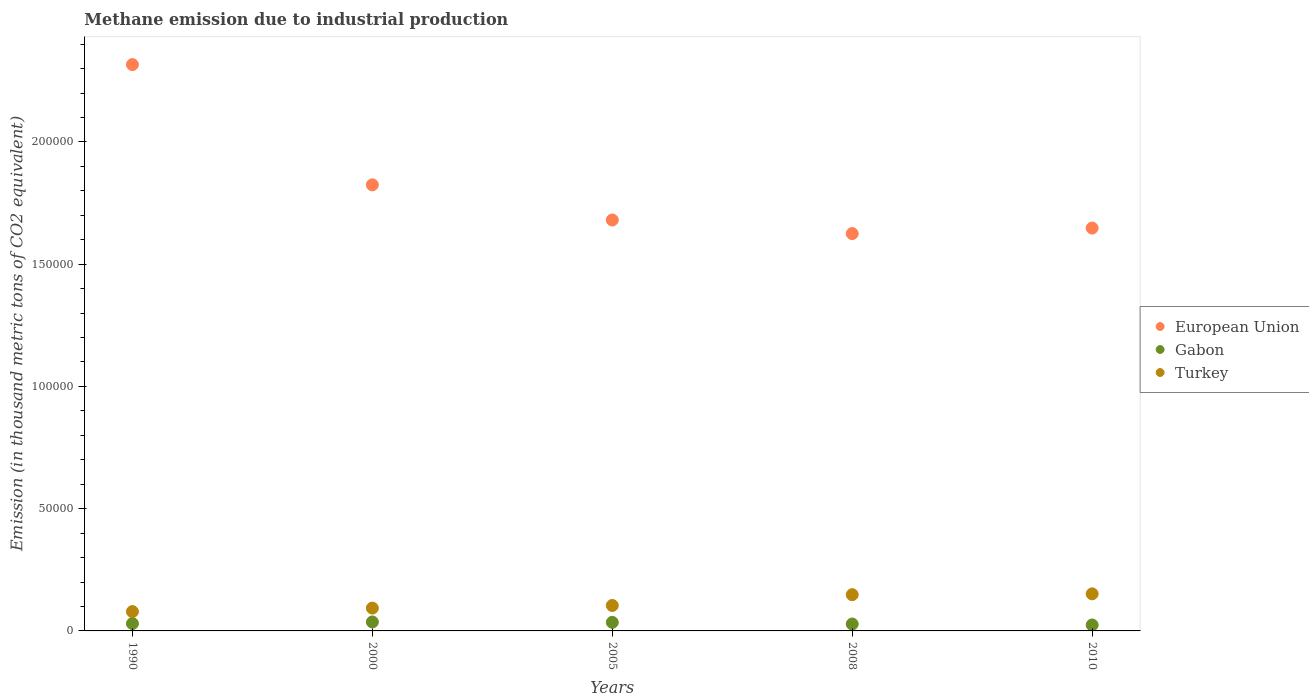How many different coloured dotlines are there?
Provide a succinct answer. 3. Is the number of dotlines equal to the number of legend labels?
Offer a terse response. Yes. What is the amount of methane emitted in European Union in 2008?
Provide a short and direct response. 1.63e+05. Across all years, what is the maximum amount of methane emitted in Gabon?
Offer a very short reply. 3670.7. Across all years, what is the minimum amount of methane emitted in European Union?
Your response must be concise. 1.63e+05. In which year was the amount of methane emitted in Turkey minimum?
Ensure brevity in your answer.  1990. What is the total amount of methane emitted in European Union in the graph?
Provide a succinct answer. 9.09e+05. What is the difference between the amount of methane emitted in Gabon in 2000 and that in 2008?
Give a very brief answer. 842.7. What is the difference between the amount of methane emitted in European Union in 2000 and the amount of methane emitted in Gabon in 2008?
Offer a very short reply. 1.80e+05. What is the average amount of methane emitted in Turkey per year?
Make the answer very short. 1.15e+04. In the year 2008, what is the difference between the amount of methane emitted in Turkey and amount of methane emitted in European Union?
Offer a terse response. -1.48e+05. In how many years, is the amount of methane emitted in European Union greater than 210000 thousand metric tons?
Offer a terse response. 1. What is the ratio of the amount of methane emitted in Gabon in 1990 to that in 2010?
Make the answer very short. 1.23. Is the amount of methane emitted in European Union in 1990 less than that in 2008?
Keep it short and to the point. No. Is the difference between the amount of methane emitted in Turkey in 2000 and 2005 greater than the difference between the amount of methane emitted in European Union in 2000 and 2005?
Provide a short and direct response. No. What is the difference between the highest and the second highest amount of methane emitted in Turkey?
Provide a succinct answer. 343.5. What is the difference between the highest and the lowest amount of methane emitted in Turkey?
Your answer should be compact. 7253.5. Is it the case that in every year, the sum of the amount of methane emitted in European Union and amount of methane emitted in Gabon  is greater than the amount of methane emitted in Turkey?
Give a very brief answer. Yes. Does the amount of methane emitted in European Union monotonically increase over the years?
Offer a terse response. No. Is the amount of methane emitted in Gabon strictly greater than the amount of methane emitted in Turkey over the years?
Provide a short and direct response. No. Is the amount of methane emitted in European Union strictly less than the amount of methane emitted in Gabon over the years?
Provide a succinct answer. No. What is the difference between two consecutive major ticks on the Y-axis?
Give a very brief answer. 5.00e+04. Does the graph contain grids?
Offer a very short reply. No. What is the title of the graph?
Offer a terse response. Methane emission due to industrial production. What is the label or title of the Y-axis?
Your answer should be compact. Emission (in thousand metric tons of CO2 equivalent). What is the Emission (in thousand metric tons of CO2 equivalent) of European Union in 1990?
Provide a succinct answer. 2.32e+05. What is the Emission (in thousand metric tons of CO2 equivalent) in Gabon in 1990?
Keep it short and to the point. 2998.2. What is the Emission (in thousand metric tons of CO2 equivalent) of Turkey in 1990?
Offer a terse response. 7912.1. What is the Emission (in thousand metric tons of CO2 equivalent) in European Union in 2000?
Your response must be concise. 1.82e+05. What is the Emission (in thousand metric tons of CO2 equivalent) of Gabon in 2000?
Your answer should be compact. 3670.7. What is the Emission (in thousand metric tons of CO2 equivalent) in Turkey in 2000?
Make the answer very short. 9337. What is the Emission (in thousand metric tons of CO2 equivalent) of European Union in 2005?
Give a very brief answer. 1.68e+05. What is the Emission (in thousand metric tons of CO2 equivalent) in Gabon in 2005?
Give a very brief answer. 3504.5. What is the Emission (in thousand metric tons of CO2 equivalent) in Turkey in 2005?
Offer a very short reply. 1.04e+04. What is the Emission (in thousand metric tons of CO2 equivalent) of European Union in 2008?
Ensure brevity in your answer.  1.63e+05. What is the Emission (in thousand metric tons of CO2 equivalent) in Gabon in 2008?
Ensure brevity in your answer.  2828. What is the Emission (in thousand metric tons of CO2 equivalent) of Turkey in 2008?
Ensure brevity in your answer.  1.48e+04. What is the Emission (in thousand metric tons of CO2 equivalent) of European Union in 2010?
Make the answer very short. 1.65e+05. What is the Emission (in thousand metric tons of CO2 equivalent) of Gabon in 2010?
Your answer should be very brief. 2434.4. What is the Emission (in thousand metric tons of CO2 equivalent) of Turkey in 2010?
Your answer should be very brief. 1.52e+04. Across all years, what is the maximum Emission (in thousand metric tons of CO2 equivalent) of European Union?
Your response must be concise. 2.32e+05. Across all years, what is the maximum Emission (in thousand metric tons of CO2 equivalent) of Gabon?
Your answer should be very brief. 3670.7. Across all years, what is the maximum Emission (in thousand metric tons of CO2 equivalent) in Turkey?
Your response must be concise. 1.52e+04. Across all years, what is the minimum Emission (in thousand metric tons of CO2 equivalent) of European Union?
Keep it short and to the point. 1.63e+05. Across all years, what is the minimum Emission (in thousand metric tons of CO2 equivalent) of Gabon?
Your answer should be compact. 2434.4. Across all years, what is the minimum Emission (in thousand metric tons of CO2 equivalent) of Turkey?
Make the answer very short. 7912.1. What is the total Emission (in thousand metric tons of CO2 equivalent) in European Union in the graph?
Offer a very short reply. 9.09e+05. What is the total Emission (in thousand metric tons of CO2 equivalent) in Gabon in the graph?
Keep it short and to the point. 1.54e+04. What is the total Emission (in thousand metric tons of CO2 equivalent) of Turkey in the graph?
Provide a short and direct response. 5.76e+04. What is the difference between the Emission (in thousand metric tons of CO2 equivalent) of European Union in 1990 and that in 2000?
Provide a succinct answer. 4.92e+04. What is the difference between the Emission (in thousand metric tons of CO2 equivalent) of Gabon in 1990 and that in 2000?
Provide a succinct answer. -672.5. What is the difference between the Emission (in thousand metric tons of CO2 equivalent) of Turkey in 1990 and that in 2000?
Your response must be concise. -1424.9. What is the difference between the Emission (in thousand metric tons of CO2 equivalent) in European Union in 1990 and that in 2005?
Provide a succinct answer. 6.36e+04. What is the difference between the Emission (in thousand metric tons of CO2 equivalent) of Gabon in 1990 and that in 2005?
Offer a terse response. -506.3. What is the difference between the Emission (in thousand metric tons of CO2 equivalent) of Turkey in 1990 and that in 2005?
Ensure brevity in your answer.  -2494.3. What is the difference between the Emission (in thousand metric tons of CO2 equivalent) of European Union in 1990 and that in 2008?
Give a very brief answer. 6.91e+04. What is the difference between the Emission (in thousand metric tons of CO2 equivalent) of Gabon in 1990 and that in 2008?
Ensure brevity in your answer.  170.2. What is the difference between the Emission (in thousand metric tons of CO2 equivalent) of Turkey in 1990 and that in 2008?
Give a very brief answer. -6910. What is the difference between the Emission (in thousand metric tons of CO2 equivalent) of European Union in 1990 and that in 2010?
Keep it short and to the point. 6.69e+04. What is the difference between the Emission (in thousand metric tons of CO2 equivalent) of Gabon in 1990 and that in 2010?
Make the answer very short. 563.8. What is the difference between the Emission (in thousand metric tons of CO2 equivalent) of Turkey in 1990 and that in 2010?
Make the answer very short. -7253.5. What is the difference between the Emission (in thousand metric tons of CO2 equivalent) in European Union in 2000 and that in 2005?
Your answer should be compact. 1.44e+04. What is the difference between the Emission (in thousand metric tons of CO2 equivalent) of Gabon in 2000 and that in 2005?
Offer a terse response. 166.2. What is the difference between the Emission (in thousand metric tons of CO2 equivalent) in Turkey in 2000 and that in 2005?
Keep it short and to the point. -1069.4. What is the difference between the Emission (in thousand metric tons of CO2 equivalent) of European Union in 2000 and that in 2008?
Your answer should be compact. 1.99e+04. What is the difference between the Emission (in thousand metric tons of CO2 equivalent) of Gabon in 2000 and that in 2008?
Provide a short and direct response. 842.7. What is the difference between the Emission (in thousand metric tons of CO2 equivalent) in Turkey in 2000 and that in 2008?
Provide a short and direct response. -5485.1. What is the difference between the Emission (in thousand metric tons of CO2 equivalent) in European Union in 2000 and that in 2010?
Your answer should be very brief. 1.77e+04. What is the difference between the Emission (in thousand metric tons of CO2 equivalent) of Gabon in 2000 and that in 2010?
Offer a very short reply. 1236.3. What is the difference between the Emission (in thousand metric tons of CO2 equivalent) in Turkey in 2000 and that in 2010?
Provide a short and direct response. -5828.6. What is the difference between the Emission (in thousand metric tons of CO2 equivalent) of European Union in 2005 and that in 2008?
Offer a terse response. 5562. What is the difference between the Emission (in thousand metric tons of CO2 equivalent) of Gabon in 2005 and that in 2008?
Your answer should be compact. 676.5. What is the difference between the Emission (in thousand metric tons of CO2 equivalent) of Turkey in 2005 and that in 2008?
Offer a very short reply. -4415.7. What is the difference between the Emission (in thousand metric tons of CO2 equivalent) in European Union in 2005 and that in 2010?
Ensure brevity in your answer.  3298.2. What is the difference between the Emission (in thousand metric tons of CO2 equivalent) of Gabon in 2005 and that in 2010?
Your answer should be compact. 1070.1. What is the difference between the Emission (in thousand metric tons of CO2 equivalent) of Turkey in 2005 and that in 2010?
Provide a succinct answer. -4759.2. What is the difference between the Emission (in thousand metric tons of CO2 equivalent) in European Union in 2008 and that in 2010?
Your answer should be very brief. -2263.8. What is the difference between the Emission (in thousand metric tons of CO2 equivalent) in Gabon in 2008 and that in 2010?
Give a very brief answer. 393.6. What is the difference between the Emission (in thousand metric tons of CO2 equivalent) of Turkey in 2008 and that in 2010?
Your response must be concise. -343.5. What is the difference between the Emission (in thousand metric tons of CO2 equivalent) of European Union in 1990 and the Emission (in thousand metric tons of CO2 equivalent) of Gabon in 2000?
Your answer should be compact. 2.28e+05. What is the difference between the Emission (in thousand metric tons of CO2 equivalent) in European Union in 1990 and the Emission (in thousand metric tons of CO2 equivalent) in Turkey in 2000?
Offer a very short reply. 2.22e+05. What is the difference between the Emission (in thousand metric tons of CO2 equivalent) of Gabon in 1990 and the Emission (in thousand metric tons of CO2 equivalent) of Turkey in 2000?
Provide a short and direct response. -6338.8. What is the difference between the Emission (in thousand metric tons of CO2 equivalent) of European Union in 1990 and the Emission (in thousand metric tons of CO2 equivalent) of Gabon in 2005?
Offer a terse response. 2.28e+05. What is the difference between the Emission (in thousand metric tons of CO2 equivalent) in European Union in 1990 and the Emission (in thousand metric tons of CO2 equivalent) in Turkey in 2005?
Provide a succinct answer. 2.21e+05. What is the difference between the Emission (in thousand metric tons of CO2 equivalent) in Gabon in 1990 and the Emission (in thousand metric tons of CO2 equivalent) in Turkey in 2005?
Offer a terse response. -7408.2. What is the difference between the Emission (in thousand metric tons of CO2 equivalent) in European Union in 1990 and the Emission (in thousand metric tons of CO2 equivalent) in Gabon in 2008?
Keep it short and to the point. 2.29e+05. What is the difference between the Emission (in thousand metric tons of CO2 equivalent) in European Union in 1990 and the Emission (in thousand metric tons of CO2 equivalent) in Turkey in 2008?
Give a very brief answer. 2.17e+05. What is the difference between the Emission (in thousand metric tons of CO2 equivalent) in Gabon in 1990 and the Emission (in thousand metric tons of CO2 equivalent) in Turkey in 2008?
Provide a succinct answer. -1.18e+04. What is the difference between the Emission (in thousand metric tons of CO2 equivalent) in European Union in 1990 and the Emission (in thousand metric tons of CO2 equivalent) in Gabon in 2010?
Provide a succinct answer. 2.29e+05. What is the difference between the Emission (in thousand metric tons of CO2 equivalent) of European Union in 1990 and the Emission (in thousand metric tons of CO2 equivalent) of Turkey in 2010?
Give a very brief answer. 2.16e+05. What is the difference between the Emission (in thousand metric tons of CO2 equivalent) of Gabon in 1990 and the Emission (in thousand metric tons of CO2 equivalent) of Turkey in 2010?
Your response must be concise. -1.22e+04. What is the difference between the Emission (in thousand metric tons of CO2 equivalent) of European Union in 2000 and the Emission (in thousand metric tons of CO2 equivalent) of Gabon in 2005?
Your answer should be very brief. 1.79e+05. What is the difference between the Emission (in thousand metric tons of CO2 equivalent) in European Union in 2000 and the Emission (in thousand metric tons of CO2 equivalent) in Turkey in 2005?
Offer a very short reply. 1.72e+05. What is the difference between the Emission (in thousand metric tons of CO2 equivalent) of Gabon in 2000 and the Emission (in thousand metric tons of CO2 equivalent) of Turkey in 2005?
Give a very brief answer. -6735.7. What is the difference between the Emission (in thousand metric tons of CO2 equivalent) in European Union in 2000 and the Emission (in thousand metric tons of CO2 equivalent) in Gabon in 2008?
Offer a very short reply. 1.80e+05. What is the difference between the Emission (in thousand metric tons of CO2 equivalent) of European Union in 2000 and the Emission (in thousand metric tons of CO2 equivalent) of Turkey in 2008?
Give a very brief answer. 1.68e+05. What is the difference between the Emission (in thousand metric tons of CO2 equivalent) of Gabon in 2000 and the Emission (in thousand metric tons of CO2 equivalent) of Turkey in 2008?
Your answer should be very brief. -1.12e+04. What is the difference between the Emission (in thousand metric tons of CO2 equivalent) of European Union in 2000 and the Emission (in thousand metric tons of CO2 equivalent) of Gabon in 2010?
Keep it short and to the point. 1.80e+05. What is the difference between the Emission (in thousand metric tons of CO2 equivalent) in European Union in 2000 and the Emission (in thousand metric tons of CO2 equivalent) in Turkey in 2010?
Give a very brief answer. 1.67e+05. What is the difference between the Emission (in thousand metric tons of CO2 equivalent) in Gabon in 2000 and the Emission (in thousand metric tons of CO2 equivalent) in Turkey in 2010?
Your answer should be compact. -1.15e+04. What is the difference between the Emission (in thousand metric tons of CO2 equivalent) of European Union in 2005 and the Emission (in thousand metric tons of CO2 equivalent) of Gabon in 2008?
Ensure brevity in your answer.  1.65e+05. What is the difference between the Emission (in thousand metric tons of CO2 equivalent) in European Union in 2005 and the Emission (in thousand metric tons of CO2 equivalent) in Turkey in 2008?
Provide a short and direct response. 1.53e+05. What is the difference between the Emission (in thousand metric tons of CO2 equivalent) in Gabon in 2005 and the Emission (in thousand metric tons of CO2 equivalent) in Turkey in 2008?
Your answer should be very brief. -1.13e+04. What is the difference between the Emission (in thousand metric tons of CO2 equivalent) in European Union in 2005 and the Emission (in thousand metric tons of CO2 equivalent) in Gabon in 2010?
Offer a terse response. 1.66e+05. What is the difference between the Emission (in thousand metric tons of CO2 equivalent) in European Union in 2005 and the Emission (in thousand metric tons of CO2 equivalent) in Turkey in 2010?
Offer a very short reply. 1.53e+05. What is the difference between the Emission (in thousand metric tons of CO2 equivalent) of Gabon in 2005 and the Emission (in thousand metric tons of CO2 equivalent) of Turkey in 2010?
Offer a very short reply. -1.17e+04. What is the difference between the Emission (in thousand metric tons of CO2 equivalent) in European Union in 2008 and the Emission (in thousand metric tons of CO2 equivalent) in Gabon in 2010?
Your answer should be compact. 1.60e+05. What is the difference between the Emission (in thousand metric tons of CO2 equivalent) in European Union in 2008 and the Emission (in thousand metric tons of CO2 equivalent) in Turkey in 2010?
Your answer should be very brief. 1.47e+05. What is the difference between the Emission (in thousand metric tons of CO2 equivalent) of Gabon in 2008 and the Emission (in thousand metric tons of CO2 equivalent) of Turkey in 2010?
Your answer should be compact. -1.23e+04. What is the average Emission (in thousand metric tons of CO2 equivalent) of European Union per year?
Ensure brevity in your answer.  1.82e+05. What is the average Emission (in thousand metric tons of CO2 equivalent) of Gabon per year?
Keep it short and to the point. 3087.16. What is the average Emission (in thousand metric tons of CO2 equivalent) in Turkey per year?
Your response must be concise. 1.15e+04. In the year 1990, what is the difference between the Emission (in thousand metric tons of CO2 equivalent) of European Union and Emission (in thousand metric tons of CO2 equivalent) of Gabon?
Your answer should be very brief. 2.29e+05. In the year 1990, what is the difference between the Emission (in thousand metric tons of CO2 equivalent) of European Union and Emission (in thousand metric tons of CO2 equivalent) of Turkey?
Your answer should be compact. 2.24e+05. In the year 1990, what is the difference between the Emission (in thousand metric tons of CO2 equivalent) of Gabon and Emission (in thousand metric tons of CO2 equivalent) of Turkey?
Provide a short and direct response. -4913.9. In the year 2000, what is the difference between the Emission (in thousand metric tons of CO2 equivalent) in European Union and Emission (in thousand metric tons of CO2 equivalent) in Gabon?
Make the answer very short. 1.79e+05. In the year 2000, what is the difference between the Emission (in thousand metric tons of CO2 equivalent) in European Union and Emission (in thousand metric tons of CO2 equivalent) in Turkey?
Your response must be concise. 1.73e+05. In the year 2000, what is the difference between the Emission (in thousand metric tons of CO2 equivalent) of Gabon and Emission (in thousand metric tons of CO2 equivalent) of Turkey?
Offer a terse response. -5666.3. In the year 2005, what is the difference between the Emission (in thousand metric tons of CO2 equivalent) of European Union and Emission (in thousand metric tons of CO2 equivalent) of Gabon?
Give a very brief answer. 1.65e+05. In the year 2005, what is the difference between the Emission (in thousand metric tons of CO2 equivalent) in European Union and Emission (in thousand metric tons of CO2 equivalent) in Turkey?
Make the answer very short. 1.58e+05. In the year 2005, what is the difference between the Emission (in thousand metric tons of CO2 equivalent) of Gabon and Emission (in thousand metric tons of CO2 equivalent) of Turkey?
Give a very brief answer. -6901.9. In the year 2008, what is the difference between the Emission (in thousand metric tons of CO2 equivalent) in European Union and Emission (in thousand metric tons of CO2 equivalent) in Gabon?
Make the answer very short. 1.60e+05. In the year 2008, what is the difference between the Emission (in thousand metric tons of CO2 equivalent) of European Union and Emission (in thousand metric tons of CO2 equivalent) of Turkey?
Ensure brevity in your answer.  1.48e+05. In the year 2008, what is the difference between the Emission (in thousand metric tons of CO2 equivalent) in Gabon and Emission (in thousand metric tons of CO2 equivalent) in Turkey?
Your answer should be very brief. -1.20e+04. In the year 2010, what is the difference between the Emission (in thousand metric tons of CO2 equivalent) in European Union and Emission (in thousand metric tons of CO2 equivalent) in Gabon?
Your answer should be very brief. 1.62e+05. In the year 2010, what is the difference between the Emission (in thousand metric tons of CO2 equivalent) of European Union and Emission (in thousand metric tons of CO2 equivalent) of Turkey?
Give a very brief answer. 1.50e+05. In the year 2010, what is the difference between the Emission (in thousand metric tons of CO2 equivalent) in Gabon and Emission (in thousand metric tons of CO2 equivalent) in Turkey?
Ensure brevity in your answer.  -1.27e+04. What is the ratio of the Emission (in thousand metric tons of CO2 equivalent) of European Union in 1990 to that in 2000?
Keep it short and to the point. 1.27. What is the ratio of the Emission (in thousand metric tons of CO2 equivalent) of Gabon in 1990 to that in 2000?
Ensure brevity in your answer.  0.82. What is the ratio of the Emission (in thousand metric tons of CO2 equivalent) of Turkey in 1990 to that in 2000?
Provide a short and direct response. 0.85. What is the ratio of the Emission (in thousand metric tons of CO2 equivalent) of European Union in 1990 to that in 2005?
Your response must be concise. 1.38. What is the ratio of the Emission (in thousand metric tons of CO2 equivalent) in Gabon in 1990 to that in 2005?
Make the answer very short. 0.86. What is the ratio of the Emission (in thousand metric tons of CO2 equivalent) of Turkey in 1990 to that in 2005?
Make the answer very short. 0.76. What is the ratio of the Emission (in thousand metric tons of CO2 equivalent) of European Union in 1990 to that in 2008?
Give a very brief answer. 1.43. What is the ratio of the Emission (in thousand metric tons of CO2 equivalent) in Gabon in 1990 to that in 2008?
Give a very brief answer. 1.06. What is the ratio of the Emission (in thousand metric tons of CO2 equivalent) of Turkey in 1990 to that in 2008?
Give a very brief answer. 0.53. What is the ratio of the Emission (in thousand metric tons of CO2 equivalent) in European Union in 1990 to that in 2010?
Your response must be concise. 1.41. What is the ratio of the Emission (in thousand metric tons of CO2 equivalent) of Gabon in 1990 to that in 2010?
Your response must be concise. 1.23. What is the ratio of the Emission (in thousand metric tons of CO2 equivalent) in Turkey in 1990 to that in 2010?
Ensure brevity in your answer.  0.52. What is the ratio of the Emission (in thousand metric tons of CO2 equivalent) of European Union in 2000 to that in 2005?
Give a very brief answer. 1.09. What is the ratio of the Emission (in thousand metric tons of CO2 equivalent) of Gabon in 2000 to that in 2005?
Your answer should be compact. 1.05. What is the ratio of the Emission (in thousand metric tons of CO2 equivalent) of Turkey in 2000 to that in 2005?
Ensure brevity in your answer.  0.9. What is the ratio of the Emission (in thousand metric tons of CO2 equivalent) of European Union in 2000 to that in 2008?
Provide a short and direct response. 1.12. What is the ratio of the Emission (in thousand metric tons of CO2 equivalent) of Gabon in 2000 to that in 2008?
Provide a short and direct response. 1.3. What is the ratio of the Emission (in thousand metric tons of CO2 equivalent) of Turkey in 2000 to that in 2008?
Ensure brevity in your answer.  0.63. What is the ratio of the Emission (in thousand metric tons of CO2 equivalent) in European Union in 2000 to that in 2010?
Ensure brevity in your answer.  1.11. What is the ratio of the Emission (in thousand metric tons of CO2 equivalent) in Gabon in 2000 to that in 2010?
Your response must be concise. 1.51. What is the ratio of the Emission (in thousand metric tons of CO2 equivalent) in Turkey in 2000 to that in 2010?
Make the answer very short. 0.62. What is the ratio of the Emission (in thousand metric tons of CO2 equivalent) in European Union in 2005 to that in 2008?
Offer a terse response. 1.03. What is the ratio of the Emission (in thousand metric tons of CO2 equivalent) in Gabon in 2005 to that in 2008?
Provide a succinct answer. 1.24. What is the ratio of the Emission (in thousand metric tons of CO2 equivalent) of Turkey in 2005 to that in 2008?
Your answer should be compact. 0.7. What is the ratio of the Emission (in thousand metric tons of CO2 equivalent) in Gabon in 2005 to that in 2010?
Provide a succinct answer. 1.44. What is the ratio of the Emission (in thousand metric tons of CO2 equivalent) in Turkey in 2005 to that in 2010?
Ensure brevity in your answer.  0.69. What is the ratio of the Emission (in thousand metric tons of CO2 equivalent) of European Union in 2008 to that in 2010?
Your answer should be very brief. 0.99. What is the ratio of the Emission (in thousand metric tons of CO2 equivalent) of Gabon in 2008 to that in 2010?
Provide a succinct answer. 1.16. What is the ratio of the Emission (in thousand metric tons of CO2 equivalent) in Turkey in 2008 to that in 2010?
Provide a short and direct response. 0.98. What is the difference between the highest and the second highest Emission (in thousand metric tons of CO2 equivalent) of European Union?
Give a very brief answer. 4.92e+04. What is the difference between the highest and the second highest Emission (in thousand metric tons of CO2 equivalent) in Gabon?
Ensure brevity in your answer.  166.2. What is the difference between the highest and the second highest Emission (in thousand metric tons of CO2 equivalent) in Turkey?
Offer a very short reply. 343.5. What is the difference between the highest and the lowest Emission (in thousand metric tons of CO2 equivalent) of European Union?
Provide a short and direct response. 6.91e+04. What is the difference between the highest and the lowest Emission (in thousand metric tons of CO2 equivalent) in Gabon?
Keep it short and to the point. 1236.3. What is the difference between the highest and the lowest Emission (in thousand metric tons of CO2 equivalent) in Turkey?
Keep it short and to the point. 7253.5. 